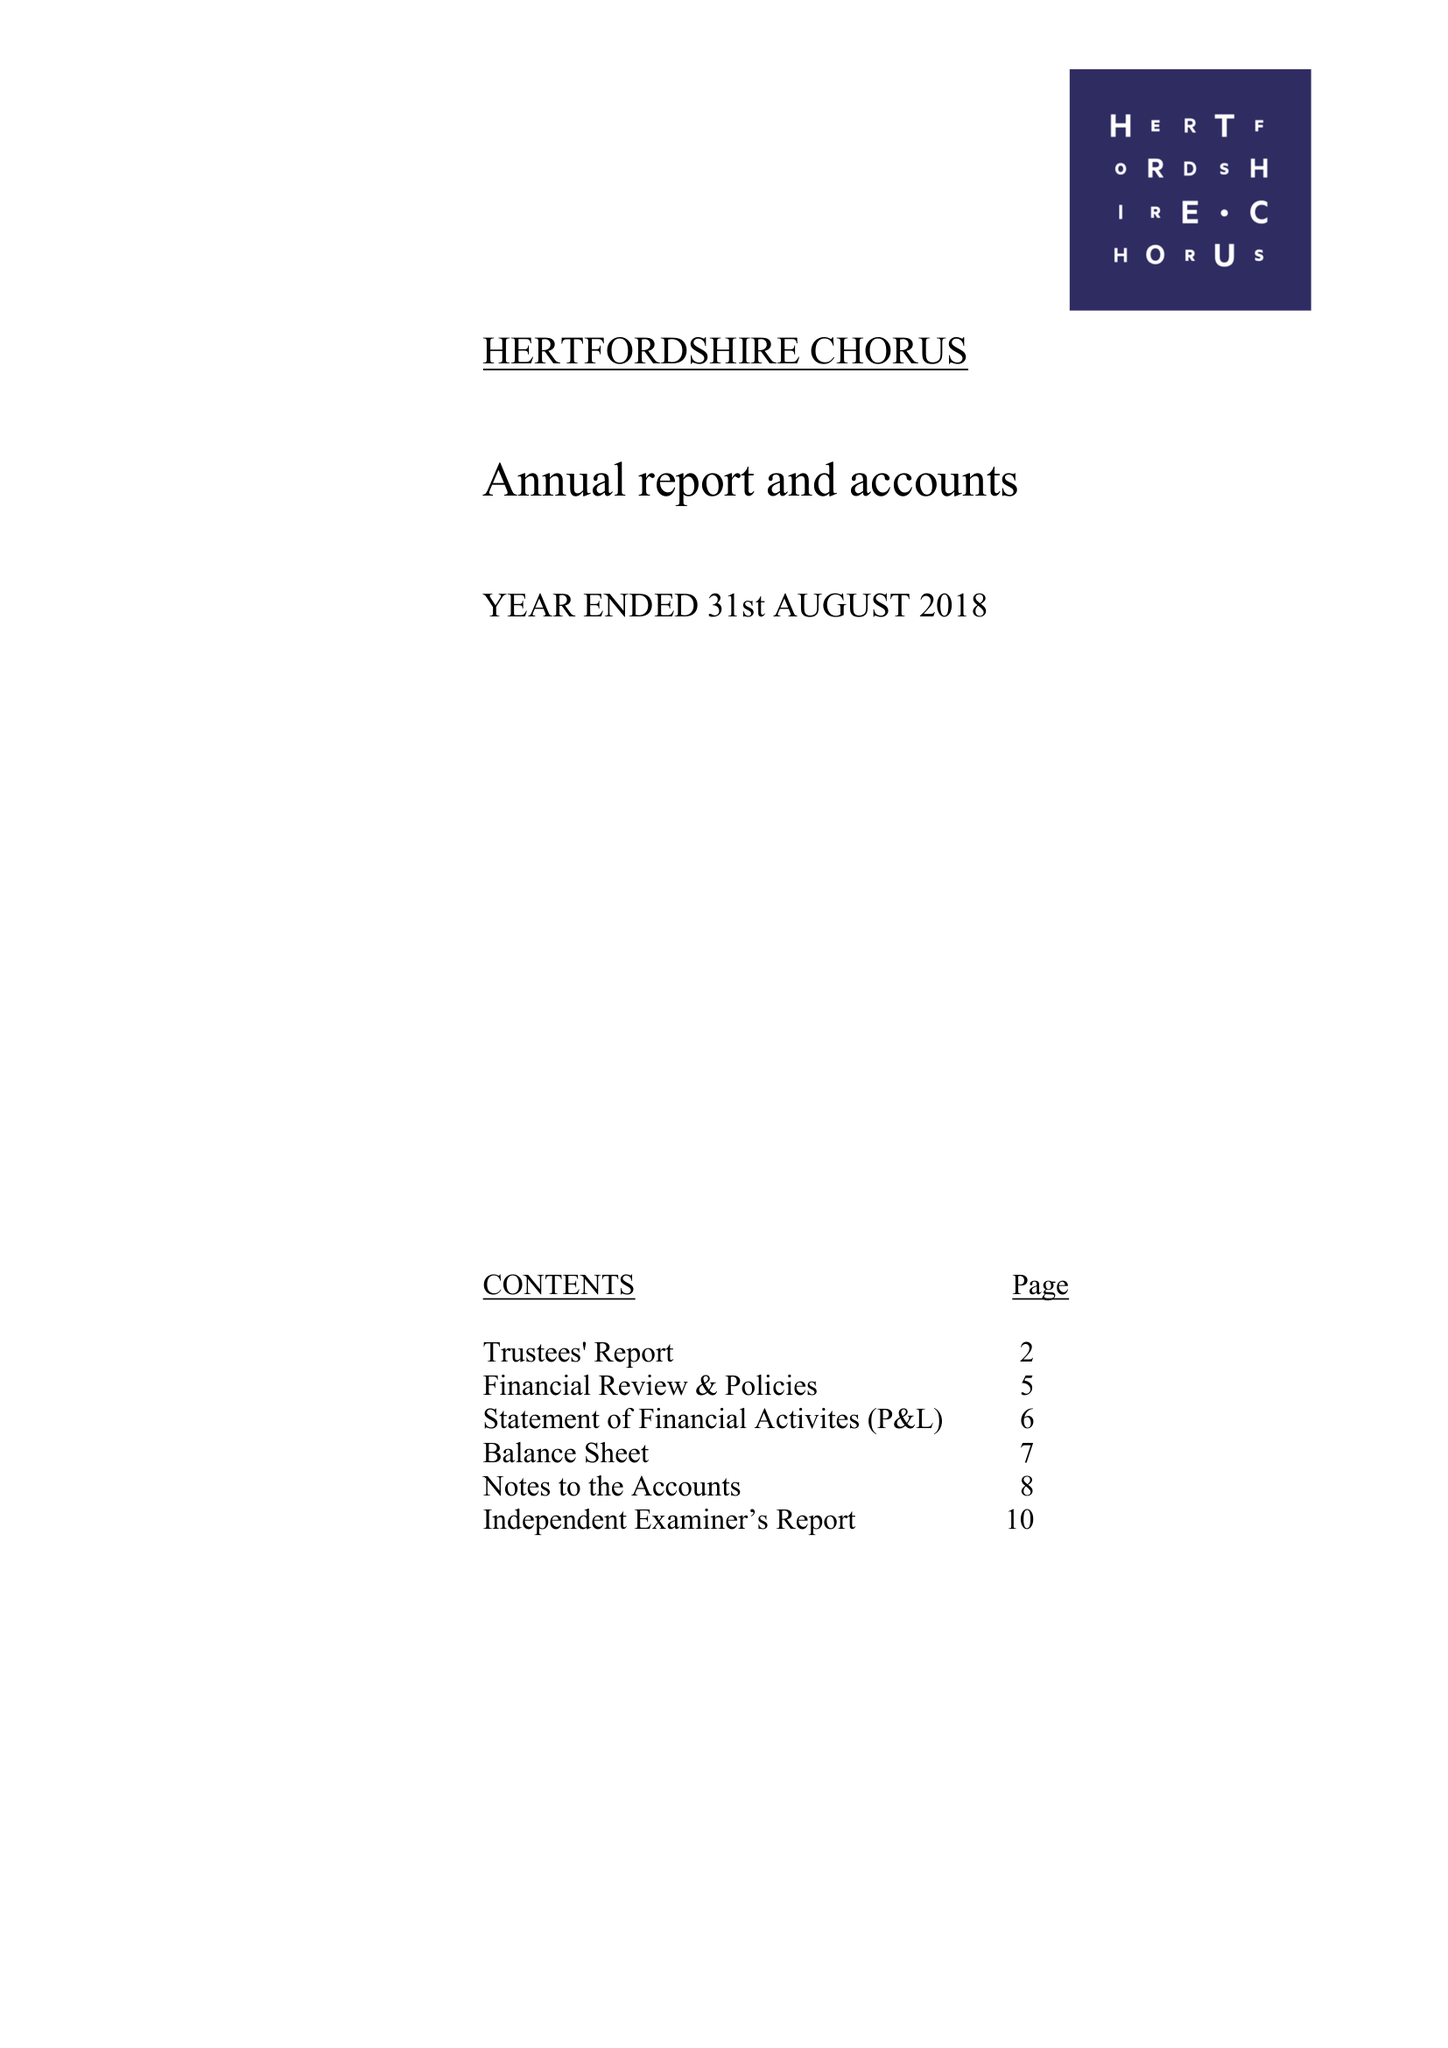What is the value for the charity_number?
Answer the question using a single word or phrase. 281627 